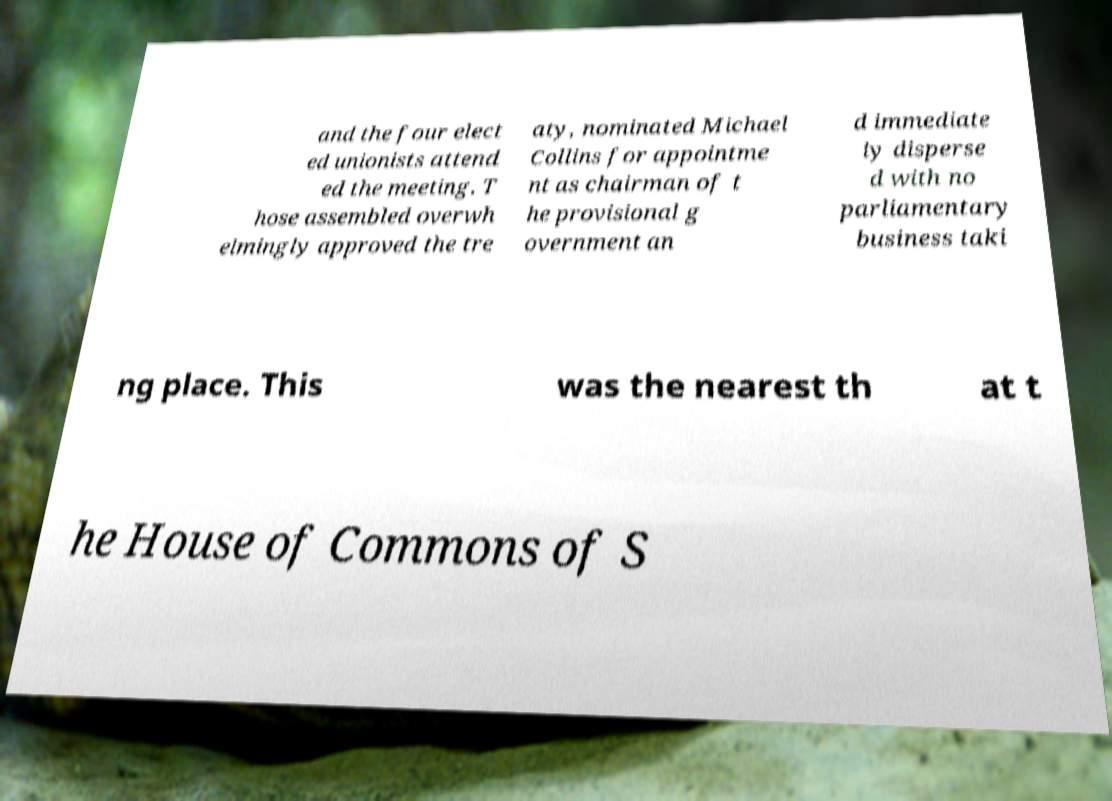What messages or text are displayed in this image? I need them in a readable, typed format. and the four elect ed unionists attend ed the meeting. T hose assembled overwh elmingly approved the tre aty, nominated Michael Collins for appointme nt as chairman of t he provisional g overnment an d immediate ly disperse d with no parliamentary business taki ng place. This was the nearest th at t he House of Commons of S 